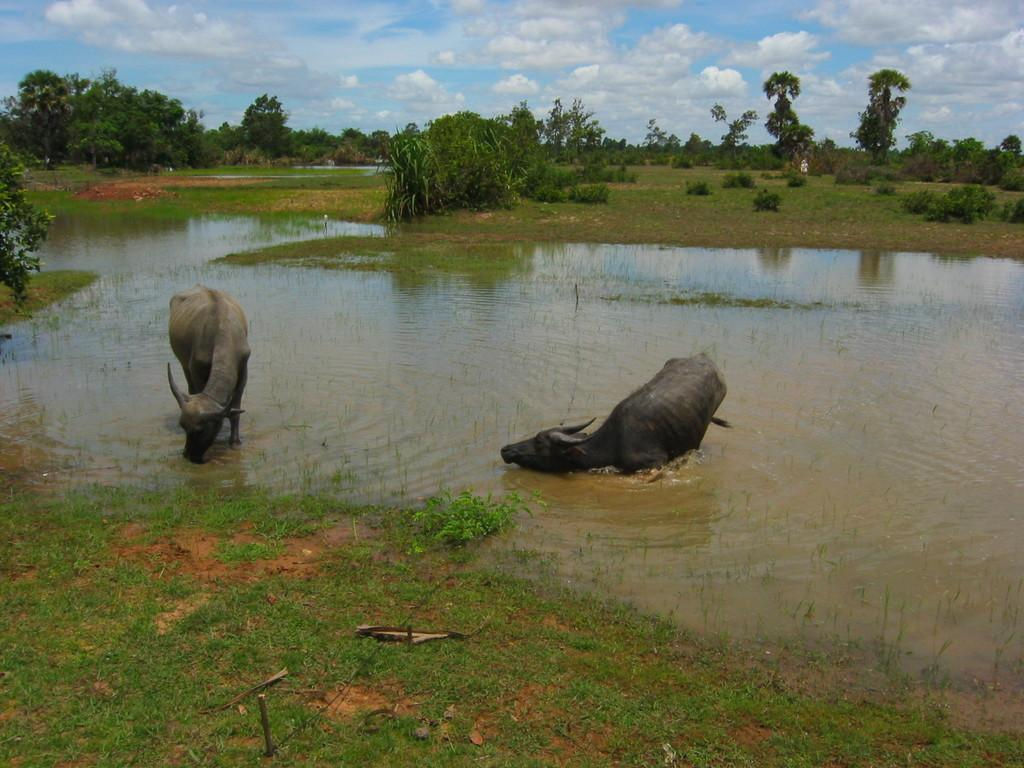What type of terrain is depicted in the image? There is a land in the image. What can be seen on the land? There is water on the land. What animals are present in the water? There are two buffaloes in the water. What can be seen in the background of the image? There are trees and the sky visible in the background of the image. What is the weight of the twig that the maid is holding in the image? There is no twig or maid present in the image. 